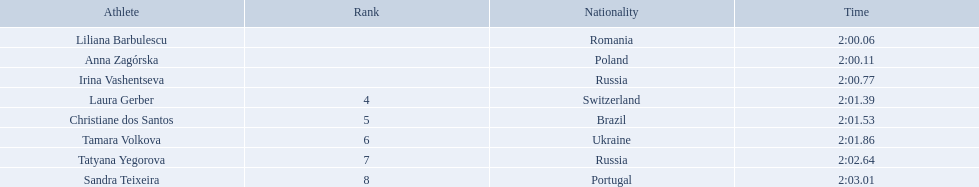What were all the finishing times? 2:00.06, 2:00.11, 2:00.77, 2:01.39, 2:01.53, 2:01.86, 2:02.64, 2:03.01. Which of these is anna zagorska's? 2:00.11. 